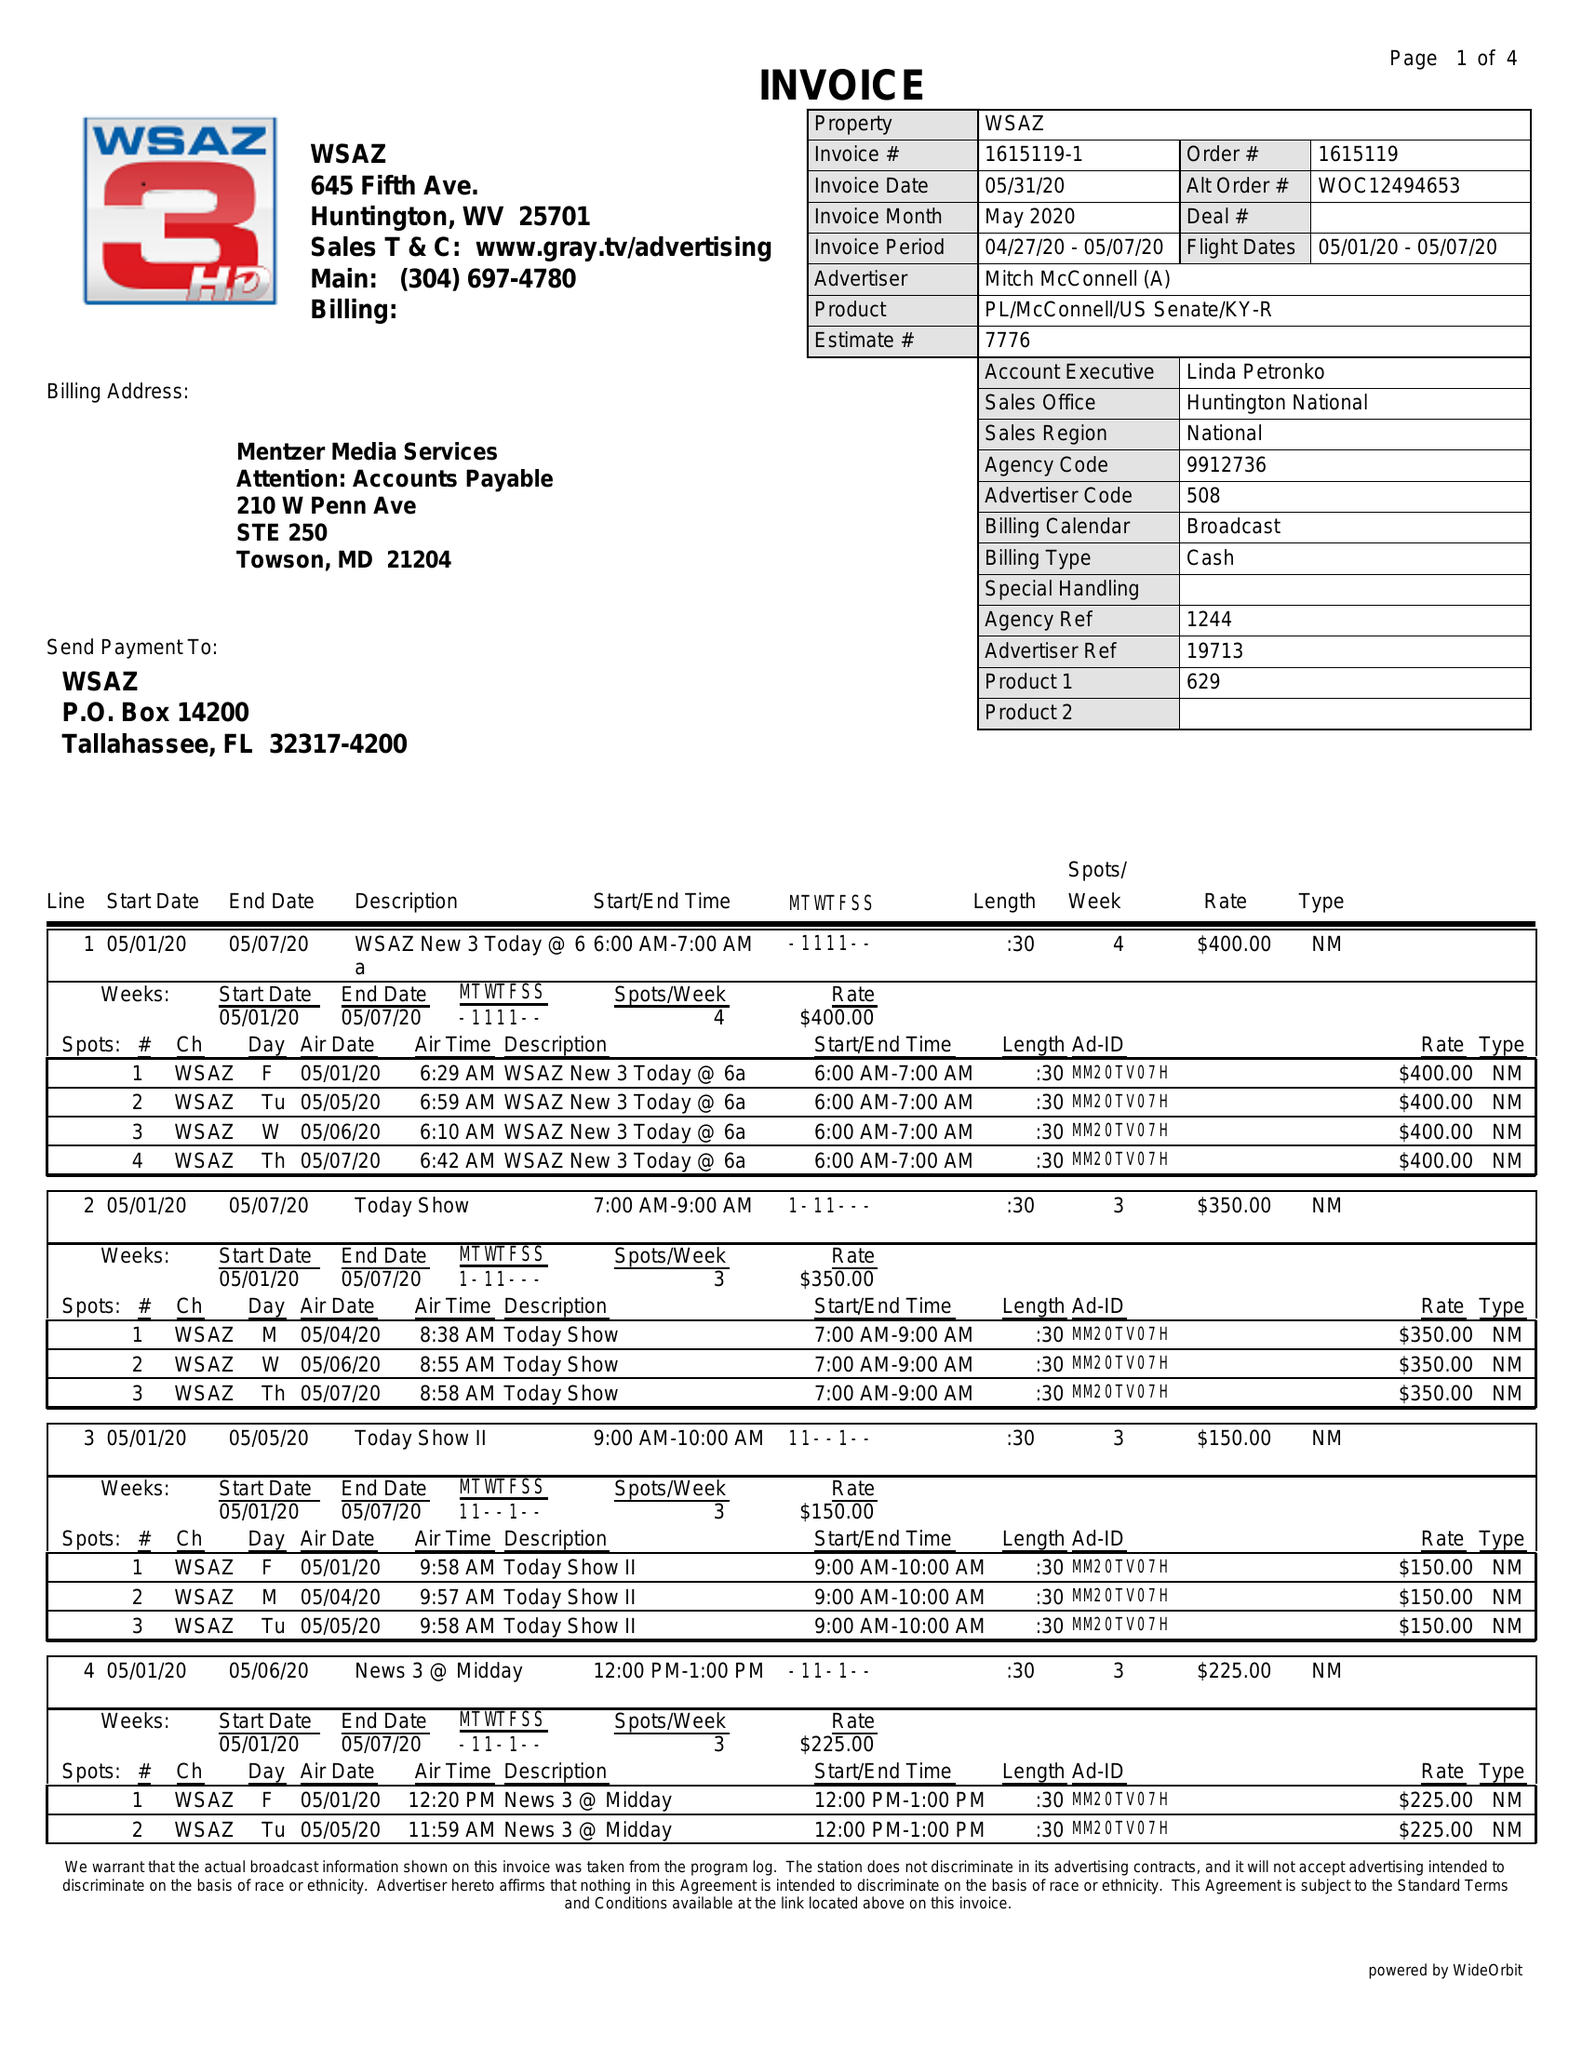What is the value for the flight_from?
Answer the question using a single word or phrase. 05/01/20 